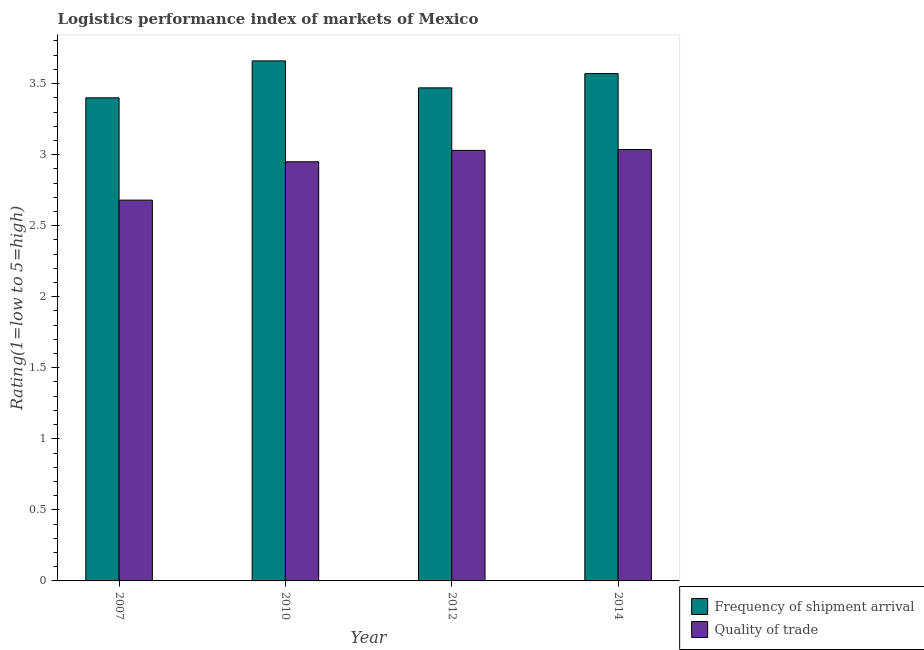How many different coloured bars are there?
Provide a short and direct response. 2. How many groups of bars are there?
Give a very brief answer. 4. Are the number of bars per tick equal to the number of legend labels?
Your answer should be compact. Yes. Are the number of bars on each tick of the X-axis equal?
Your answer should be very brief. Yes. What is the label of the 4th group of bars from the left?
Give a very brief answer. 2014. In how many cases, is the number of bars for a given year not equal to the number of legend labels?
Your answer should be very brief. 0. What is the lpi quality of trade in 2012?
Ensure brevity in your answer.  3.03. Across all years, what is the maximum lpi of frequency of shipment arrival?
Give a very brief answer. 3.66. Across all years, what is the minimum lpi quality of trade?
Provide a short and direct response. 2.68. What is the total lpi quality of trade in the graph?
Offer a very short reply. 11.7. What is the difference between the lpi of frequency of shipment arrival in 2010 and that in 2014?
Give a very brief answer. 0.09. What is the difference between the lpi quality of trade in 2010 and the lpi of frequency of shipment arrival in 2014?
Provide a short and direct response. -0.09. What is the average lpi quality of trade per year?
Keep it short and to the point. 2.92. In the year 2014, what is the difference between the lpi quality of trade and lpi of frequency of shipment arrival?
Provide a succinct answer. 0. What is the ratio of the lpi quality of trade in 2007 to that in 2014?
Offer a terse response. 0.88. Is the difference between the lpi of frequency of shipment arrival in 2007 and 2012 greater than the difference between the lpi quality of trade in 2007 and 2012?
Your answer should be very brief. No. What is the difference between the highest and the second highest lpi quality of trade?
Provide a short and direct response. 0.01. What is the difference between the highest and the lowest lpi of frequency of shipment arrival?
Provide a succinct answer. 0.26. In how many years, is the lpi quality of trade greater than the average lpi quality of trade taken over all years?
Your response must be concise. 3. Is the sum of the lpi of frequency of shipment arrival in 2007 and 2010 greater than the maximum lpi quality of trade across all years?
Keep it short and to the point. Yes. What does the 2nd bar from the left in 2014 represents?
Offer a very short reply. Quality of trade. What does the 2nd bar from the right in 2014 represents?
Make the answer very short. Frequency of shipment arrival. How many bars are there?
Your answer should be compact. 8. What is the difference between two consecutive major ticks on the Y-axis?
Make the answer very short. 0.5. Are the values on the major ticks of Y-axis written in scientific E-notation?
Give a very brief answer. No. Does the graph contain any zero values?
Make the answer very short. No. Does the graph contain grids?
Provide a short and direct response. No. How many legend labels are there?
Make the answer very short. 2. How are the legend labels stacked?
Provide a short and direct response. Vertical. What is the title of the graph?
Keep it short and to the point. Logistics performance index of markets of Mexico. What is the label or title of the X-axis?
Your answer should be compact. Year. What is the label or title of the Y-axis?
Offer a terse response. Rating(1=low to 5=high). What is the Rating(1=low to 5=high) of Quality of trade in 2007?
Offer a terse response. 2.68. What is the Rating(1=low to 5=high) of Frequency of shipment arrival in 2010?
Provide a short and direct response. 3.66. What is the Rating(1=low to 5=high) in Quality of trade in 2010?
Offer a very short reply. 2.95. What is the Rating(1=low to 5=high) of Frequency of shipment arrival in 2012?
Your response must be concise. 3.47. What is the Rating(1=low to 5=high) of Quality of trade in 2012?
Make the answer very short. 3.03. What is the Rating(1=low to 5=high) of Frequency of shipment arrival in 2014?
Make the answer very short. 3.57. What is the Rating(1=low to 5=high) in Quality of trade in 2014?
Make the answer very short. 3.04. Across all years, what is the maximum Rating(1=low to 5=high) in Frequency of shipment arrival?
Offer a very short reply. 3.66. Across all years, what is the maximum Rating(1=low to 5=high) in Quality of trade?
Give a very brief answer. 3.04. Across all years, what is the minimum Rating(1=low to 5=high) in Quality of trade?
Your answer should be very brief. 2.68. What is the total Rating(1=low to 5=high) of Frequency of shipment arrival in the graph?
Offer a terse response. 14.1. What is the total Rating(1=low to 5=high) of Quality of trade in the graph?
Make the answer very short. 11.7. What is the difference between the Rating(1=low to 5=high) of Frequency of shipment arrival in 2007 and that in 2010?
Provide a succinct answer. -0.26. What is the difference between the Rating(1=low to 5=high) in Quality of trade in 2007 and that in 2010?
Offer a terse response. -0.27. What is the difference between the Rating(1=low to 5=high) of Frequency of shipment arrival in 2007 and that in 2012?
Make the answer very short. -0.07. What is the difference between the Rating(1=low to 5=high) in Quality of trade in 2007 and that in 2012?
Provide a succinct answer. -0.35. What is the difference between the Rating(1=low to 5=high) of Frequency of shipment arrival in 2007 and that in 2014?
Ensure brevity in your answer.  -0.17. What is the difference between the Rating(1=low to 5=high) of Quality of trade in 2007 and that in 2014?
Offer a terse response. -0.36. What is the difference between the Rating(1=low to 5=high) in Frequency of shipment arrival in 2010 and that in 2012?
Make the answer very short. 0.19. What is the difference between the Rating(1=low to 5=high) of Quality of trade in 2010 and that in 2012?
Offer a terse response. -0.08. What is the difference between the Rating(1=low to 5=high) in Frequency of shipment arrival in 2010 and that in 2014?
Ensure brevity in your answer.  0.09. What is the difference between the Rating(1=low to 5=high) in Quality of trade in 2010 and that in 2014?
Give a very brief answer. -0.09. What is the difference between the Rating(1=low to 5=high) of Frequency of shipment arrival in 2012 and that in 2014?
Your answer should be very brief. -0.1. What is the difference between the Rating(1=low to 5=high) of Quality of trade in 2012 and that in 2014?
Your response must be concise. -0.01. What is the difference between the Rating(1=low to 5=high) in Frequency of shipment arrival in 2007 and the Rating(1=low to 5=high) in Quality of trade in 2010?
Your answer should be very brief. 0.45. What is the difference between the Rating(1=low to 5=high) in Frequency of shipment arrival in 2007 and the Rating(1=low to 5=high) in Quality of trade in 2012?
Give a very brief answer. 0.37. What is the difference between the Rating(1=low to 5=high) of Frequency of shipment arrival in 2007 and the Rating(1=low to 5=high) of Quality of trade in 2014?
Your answer should be very brief. 0.36. What is the difference between the Rating(1=low to 5=high) of Frequency of shipment arrival in 2010 and the Rating(1=low to 5=high) of Quality of trade in 2012?
Your response must be concise. 0.63. What is the difference between the Rating(1=low to 5=high) in Frequency of shipment arrival in 2010 and the Rating(1=low to 5=high) in Quality of trade in 2014?
Keep it short and to the point. 0.62. What is the difference between the Rating(1=low to 5=high) of Frequency of shipment arrival in 2012 and the Rating(1=low to 5=high) of Quality of trade in 2014?
Your answer should be very brief. 0.43. What is the average Rating(1=low to 5=high) of Frequency of shipment arrival per year?
Make the answer very short. 3.53. What is the average Rating(1=low to 5=high) of Quality of trade per year?
Provide a succinct answer. 2.92. In the year 2007, what is the difference between the Rating(1=low to 5=high) in Frequency of shipment arrival and Rating(1=low to 5=high) in Quality of trade?
Ensure brevity in your answer.  0.72. In the year 2010, what is the difference between the Rating(1=low to 5=high) in Frequency of shipment arrival and Rating(1=low to 5=high) in Quality of trade?
Your response must be concise. 0.71. In the year 2012, what is the difference between the Rating(1=low to 5=high) of Frequency of shipment arrival and Rating(1=low to 5=high) of Quality of trade?
Give a very brief answer. 0.44. In the year 2014, what is the difference between the Rating(1=low to 5=high) of Frequency of shipment arrival and Rating(1=low to 5=high) of Quality of trade?
Your answer should be compact. 0.53. What is the ratio of the Rating(1=low to 5=high) in Frequency of shipment arrival in 2007 to that in 2010?
Offer a very short reply. 0.93. What is the ratio of the Rating(1=low to 5=high) of Quality of trade in 2007 to that in 2010?
Provide a short and direct response. 0.91. What is the ratio of the Rating(1=low to 5=high) of Frequency of shipment arrival in 2007 to that in 2012?
Keep it short and to the point. 0.98. What is the ratio of the Rating(1=low to 5=high) of Quality of trade in 2007 to that in 2012?
Offer a very short reply. 0.88. What is the ratio of the Rating(1=low to 5=high) of Frequency of shipment arrival in 2007 to that in 2014?
Your answer should be very brief. 0.95. What is the ratio of the Rating(1=low to 5=high) in Quality of trade in 2007 to that in 2014?
Ensure brevity in your answer.  0.88. What is the ratio of the Rating(1=low to 5=high) in Frequency of shipment arrival in 2010 to that in 2012?
Give a very brief answer. 1.05. What is the ratio of the Rating(1=low to 5=high) in Quality of trade in 2010 to that in 2012?
Ensure brevity in your answer.  0.97. What is the ratio of the Rating(1=low to 5=high) in Frequency of shipment arrival in 2010 to that in 2014?
Keep it short and to the point. 1.03. What is the ratio of the Rating(1=low to 5=high) in Quality of trade in 2010 to that in 2014?
Make the answer very short. 0.97. What is the ratio of the Rating(1=low to 5=high) of Frequency of shipment arrival in 2012 to that in 2014?
Your response must be concise. 0.97. What is the difference between the highest and the second highest Rating(1=low to 5=high) in Frequency of shipment arrival?
Keep it short and to the point. 0.09. What is the difference between the highest and the second highest Rating(1=low to 5=high) in Quality of trade?
Ensure brevity in your answer.  0.01. What is the difference between the highest and the lowest Rating(1=low to 5=high) in Frequency of shipment arrival?
Provide a short and direct response. 0.26. What is the difference between the highest and the lowest Rating(1=low to 5=high) of Quality of trade?
Keep it short and to the point. 0.36. 